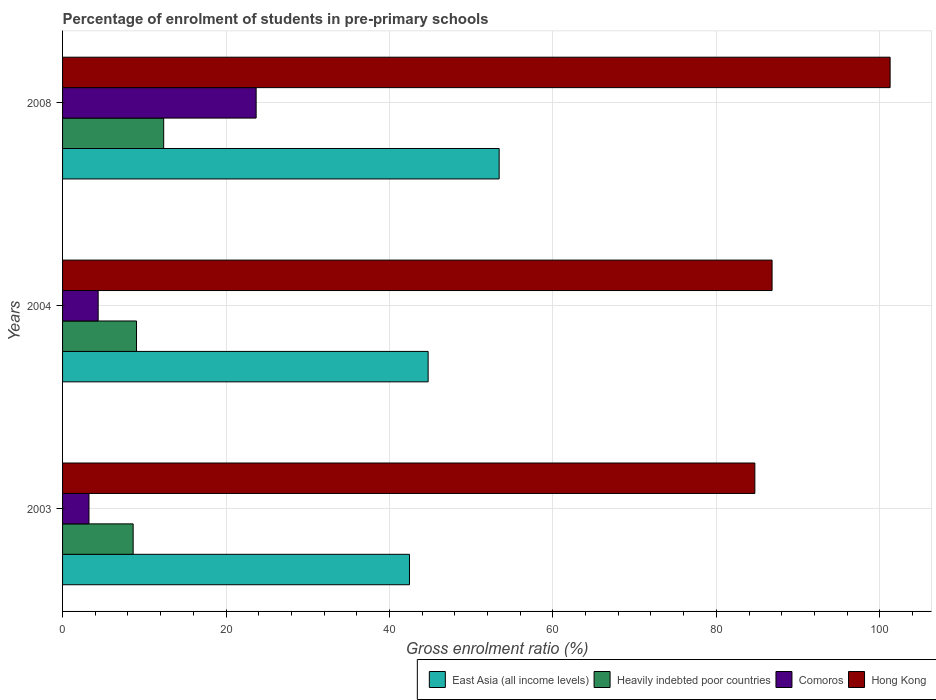How many groups of bars are there?
Ensure brevity in your answer.  3. Are the number of bars per tick equal to the number of legend labels?
Offer a very short reply. Yes. How many bars are there on the 3rd tick from the top?
Provide a short and direct response. 4. How many bars are there on the 2nd tick from the bottom?
Keep it short and to the point. 4. What is the percentage of students enrolled in pre-primary schools in East Asia (all income levels) in 2004?
Make the answer very short. 44.73. Across all years, what is the maximum percentage of students enrolled in pre-primary schools in Comoros?
Your answer should be very brief. 23.69. Across all years, what is the minimum percentage of students enrolled in pre-primary schools in Comoros?
Offer a very short reply. 3.23. In which year was the percentage of students enrolled in pre-primary schools in Comoros maximum?
Offer a terse response. 2008. What is the total percentage of students enrolled in pre-primary schools in East Asia (all income levels) in the graph?
Ensure brevity in your answer.  140.6. What is the difference between the percentage of students enrolled in pre-primary schools in Heavily indebted poor countries in 2003 and that in 2004?
Give a very brief answer. -0.41. What is the difference between the percentage of students enrolled in pre-primary schools in Hong Kong in 2004 and the percentage of students enrolled in pre-primary schools in Heavily indebted poor countries in 2003?
Ensure brevity in your answer.  78.18. What is the average percentage of students enrolled in pre-primary schools in Comoros per year?
Your answer should be compact. 10.42. In the year 2008, what is the difference between the percentage of students enrolled in pre-primary schools in Heavily indebted poor countries and percentage of students enrolled in pre-primary schools in Comoros?
Offer a terse response. -11.31. In how many years, is the percentage of students enrolled in pre-primary schools in East Asia (all income levels) greater than 96 %?
Ensure brevity in your answer.  0. What is the ratio of the percentage of students enrolled in pre-primary schools in Hong Kong in 2003 to that in 2004?
Give a very brief answer. 0.98. Is the percentage of students enrolled in pre-primary schools in East Asia (all income levels) in 2003 less than that in 2004?
Your response must be concise. Yes. What is the difference between the highest and the second highest percentage of students enrolled in pre-primary schools in Comoros?
Offer a very short reply. 19.33. What is the difference between the highest and the lowest percentage of students enrolled in pre-primary schools in Comoros?
Provide a short and direct response. 20.45. In how many years, is the percentage of students enrolled in pre-primary schools in Hong Kong greater than the average percentage of students enrolled in pre-primary schools in Hong Kong taken over all years?
Provide a short and direct response. 1. Is it the case that in every year, the sum of the percentage of students enrolled in pre-primary schools in Hong Kong and percentage of students enrolled in pre-primary schools in Comoros is greater than the sum of percentage of students enrolled in pre-primary schools in East Asia (all income levels) and percentage of students enrolled in pre-primary schools in Heavily indebted poor countries?
Ensure brevity in your answer.  Yes. What does the 3rd bar from the top in 2004 represents?
Your answer should be compact. Heavily indebted poor countries. What does the 4th bar from the bottom in 2008 represents?
Ensure brevity in your answer.  Hong Kong. Is it the case that in every year, the sum of the percentage of students enrolled in pre-primary schools in East Asia (all income levels) and percentage of students enrolled in pre-primary schools in Hong Kong is greater than the percentage of students enrolled in pre-primary schools in Comoros?
Give a very brief answer. Yes. How many bars are there?
Offer a terse response. 12. Are all the bars in the graph horizontal?
Your answer should be very brief. Yes. How many years are there in the graph?
Your answer should be very brief. 3. What is the difference between two consecutive major ticks on the X-axis?
Your response must be concise. 20. Does the graph contain any zero values?
Your answer should be very brief. No. How many legend labels are there?
Provide a short and direct response. 4. What is the title of the graph?
Keep it short and to the point. Percentage of enrolment of students in pre-primary schools. What is the Gross enrolment ratio (%) in East Asia (all income levels) in 2003?
Your answer should be compact. 42.45. What is the Gross enrolment ratio (%) in Heavily indebted poor countries in 2003?
Keep it short and to the point. 8.64. What is the Gross enrolment ratio (%) in Comoros in 2003?
Your answer should be compact. 3.23. What is the Gross enrolment ratio (%) of Hong Kong in 2003?
Provide a short and direct response. 84.71. What is the Gross enrolment ratio (%) in East Asia (all income levels) in 2004?
Provide a succinct answer. 44.73. What is the Gross enrolment ratio (%) of Heavily indebted poor countries in 2004?
Your response must be concise. 9.05. What is the Gross enrolment ratio (%) of Comoros in 2004?
Provide a succinct answer. 4.36. What is the Gross enrolment ratio (%) in Hong Kong in 2004?
Give a very brief answer. 86.82. What is the Gross enrolment ratio (%) in East Asia (all income levels) in 2008?
Your response must be concise. 53.42. What is the Gross enrolment ratio (%) of Heavily indebted poor countries in 2008?
Offer a very short reply. 12.37. What is the Gross enrolment ratio (%) of Comoros in 2008?
Keep it short and to the point. 23.69. What is the Gross enrolment ratio (%) in Hong Kong in 2008?
Give a very brief answer. 101.26. Across all years, what is the maximum Gross enrolment ratio (%) in East Asia (all income levels)?
Offer a very short reply. 53.42. Across all years, what is the maximum Gross enrolment ratio (%) in Heavily indebted poor countries?
Offer a very short reply. 12.37. Across all years, what is the maximum Gross enrolment ratio (%) in Comoros?
Make the answer very short. 23.69. Across all years, what is the maximum Gross enrolment ratio (%) of Hong Kong?
Ensure brevity in your answer.  101.26. Across all years, what is the minimum Gross enrolment ratio (%) of East Asia (all income levels)?
Provide a short and direct response. 42.45. Across all years, what is the minimum Gross enrolment ratio (%) of Heavily indebted poor countries?
Your answer should be compact. 8.64. Across all years, what is the minimum Gross enrolment ratio (%) of Comoros?
Keep it short and to the point. 3.23. Across all years, what is the minimum Gross enrolment ratio (%) in Hong Kong?
Offer a very short reply. 84.71. What is the total Gross enrolment ratio (%) in East Asia (all income levels) in the graph?
Offer a terse response. 140.6. What is the total Gross enrolment ratio (%) in Heavily indebted poor countries in the graph?
Provide a short and direct response. 30.06. What is the total Gross enrolment ratio (%) in Comoros in the graph?
Your answer should be very brief. 31.27. What is the total Gross enrolment ratio (%) in Hong Kong in the graph?
Offer a terse response. 272.79. What is the difference between the Gross enrolment ratio (%) in East Asia (all income levels) in 2003 and that in 2004?
Ensure brevity in your answer.  -2.28. What is the difference between the Gross enrolment ratio (%) of Heavily indebted poor countries in 2003 and that in 2004?
Provide a succinct answer. -0.41. What is the difference between the Gross enrolment ratio (%) in Comoros in 2003 and that in 2004?
Provide a short and direct response. -1.12. What is the difference between the Gross enrolment ratio (%) in Hong Kong in 2003 and that in 2004?
Your answer should be compact. -2.11. What is the difference between the Gross enrolment ratio (%) of East Asia (all income levels) in 2003 and that in 2008?
Offer a very short reply. -10.97. What is the difference between the Gross enrolment ratio (%) in Heavily indebted poor countries in 2003 and that in 2008?
Give a very brief answer. -3.74. What is the difference between the Gross enrolment ratio (%) in Comoros in 2003 and that in 2008?
Ensure brevity in your answer.  -20.45. What is the difference between the Gross enrolment ratio (%) in Hong Kong in 2003 and that in 2008?
Ensure brevity in your answer.  -16.55. What is the difference between the Gross enrolment ratio (%) in East Asia (all income levels) in 2004 and that in 2008?
Keep it short and to the point. -8.69. What is the difference between the Gross enrolment ratio (%) of Heavily indebted poor countries in 2004 and that in 2008?
Keep it short and to the point. -3.33. What is the difference between the Gross enrolment ratio (%) in Comoros in 2004 and that in 2008?
Provide a succinct answer. -19.33. What is the difference between the Gross enrolment ratio (%) in Hong Kong in 2004 and that in 2008?
Offer a terse response. -14.44. What is the difference between the Gross enrolment ratio (%) of East Asia (all income levels) in 2003 and the Gross enrolment ratio (%) of Heavily indebted poor countries in 2004?
Provide a succinct answer. 33.4. What is the difference between the Gross enrolment ratio (%) of East Asia (all income levels) in 2003 and the Gross enrolment ratio (%) of Comoros in 2004?
Keep it short and to the point. 38.09. What is the difference between the Gross enrolment ratio (%) of East Asia (all income levels) in 2003 and the Gross enrolment ratio (%) of Hong Kong in 2004?
Offer a terse response. -44.37. What is the difference between the Gross enrolment ratio (%) in Heavily indebted poor countries in 2003 and the Gross enrolment ratio (%) in Comoros in 2004?
Give a very brief answer. 4.28. What is the difference between the Gross enrolment ratio (%) of Heavily indebted poor countries in 2003 and the Gross enrolment ratio (%) of Hong Kong in 2004?
Provide a short and direct response. -78.18. What is the difference between the Gross enrolment ratio (%) of Comoros in 2003 and the Gross enrolment ratio (%) of Hong Kong in 2004?
Make the answer very short. -83.58. What is the difference between the Gross enrolment ratio (%) of East Asia (all income levels) in 2003 and the Gross enrolment ratio (%) of Heavily indebted poor countries in 2008?
Provide a short and direct response. 30.08. What is the difference between the Gross enrolment ratio (%) of East Asia (all income levels) in 2003 and the Gross enrolment ratio (%) of Comoros in 2008?
Your answer should be very brief. 18.76. What is the difference between the Gross enrolment ratio (%) of East Asia (all income levels) in 2003 and the Gross enrolment ratio (%) of Hong Kong in 2008?
Offer a very short reply. -58.81. What is the difference between the Gross enrolment ratio (%) in Heavily indebted poor countries in 2003 and the Gross enrolment ratio (%) in Comoros in 2008?
Give a very brief answer. -15.05. What is the difference between the Gross enrolment ratio (%) in Heavily indebted poor countries in 2003 and the Gross enrolment ratio (%) in Hong Kong in 2008?
Your answer should be compact. -92.62. What is the difference between the Gross enrolment ratio (%) of Comoros in 2003 and the Gross enrolment ratio (%) of Hong Kong in 2008?
Your response must be concise. -98.03. What is the difference between the Gross enrolment ratio (%) of East Asia (all income levels) in 2004 and the Gross enrolment ratio (%) of Heavily indebted poor countries in 2008?
Your answer should be compact. 32.36. What is the difference between the Gross enrolment ratio (%) in East Asia (all income levels) in 2004 and the Gross enrolment ratio (%) in Comoros in 2008?
Offer a very short reply. 21.05. What is the difference between the Gross enrolment ratio (%) of East Asia (all income levels) in 2004 and the Gross enrolment ratio (%) of Hong Kong in 2008?
Offer a very short reply. -56.53. What is the difference between the Gross enrolment ratio (%) in Heavily indebted poor countries in 2004 and the Gross enrolment ratio (%) in Comoros in 2008?
Keep it short and to the point. -14.64. What is the difference between the Gross enrolment ratio (%) in Heavily indebted poor countries in 2004 and the Gross enrolment ratio (%) in Hong Kong in 2008?
Offer a terse response. -92.21. What is the difference between the Gross enrolment ratio (%) in Comoros in 2004 and the Gross enrolment ratio (%) in Hong Kong in 2008?
Provide a short and direct response. -96.9. What is the average Gross enrolment ratio (%) in East Asia (all income levels) per year?
Ensure brevity in your answer.  46.87. What is the average Gross enrolment ratio (%) in Heavily indebted poor countries per year?
Provide a succinct answer. 10.02. What is the average Gross enrolment ratio (%) in Comoros per year?
Offer a terse response. 10.42. What is the average Gross enrolment ratio (%) in Hong Kong per year?
Offer a very short reply. 90.93. In the year 2003, what is the difference between the Gross enrolment ratio (%) in East Asia (all income levels) and Gross enrolment ratio (%) in Heavily indebted poor countries?
Ensure brevity in your answer.  33.81. In the year 2003, what is the difference between the Gross enrolment ratio (%) of East Asia (all income levels) and Gross enrolment ratio (%) of Comoros?
Offer a terse response. 39.22. In the year 2003, what is the difference between the Gross enrolment ratio (%) in East Asia (all income levels) and Gross enrolment ratio (%) in Hong Kong?
Provide a succinct answer. -42.26. In the year 2003, what is the difference between the Gross enrolment ratio (%) in Heavily indebted poor countries and Gross enrolment ratio (%) in Comoros?
Keep it short and to the point. 5.4. In the year 2003, what is the difference between the Gross enrolment ratio (%) in Heavily indebted poor countries and Gross enrolment ratio (%) in Hong Kong?
Ensure brevity in your answer.  -76.07. In the year 2003, what is the difference between the Gross enrolment ratio (%) in Comoros and Gross enrolment ratio (%) in Hong Kong?
Your answer should be very brief. -81.48. In the year 2004, what is the difference between the Gross enrolment ratio (%) in East Asia (all income levels) and Gross enrolment ratio (%) in Heavily indebted poor countries?
Offer a very short reply. 35.69. In the year 2004, what is the difference between the Gross enrolment ratio (%) in East Asia (all income levels) and Gross enrolment ratio (%) in Comoros?
Provide a short and direct response. 40.38. In the year 2004, what is the difference between the Gross enrolment ratio (%) of East Asia (all income levels) and Gross enrolment ratio (%) of Hong Kong?
Your answer should be compact. -42.08. In the year 2004, what is the difference between the Gross enrolment ratio (%) of Heavily indebted poor countries and Gross enrolment ratio (%) of Comoros?
Give a very brief answer. 4.69. In the year 2004, what is the difference between the Gross enrolment ratio (%) of Heavily indebted poor countries and Gross enrolment ratio (%) of Hong Kong?
Make the answer very short. -77.77. In the year 2004, what is the difference between the Gross enrolment ratio (%) in Comoros and Gross enrolment ratio (%) in Hong Kong?
Give a very brief answer. -82.46. In the year 2008, what is the difference between the Gross enrolment ratio (%) of East Asia (all income levels) and Gross enrolment ratio (%) of Heavily indebted poor countries?
Provide a succinct answer. 41.05. In the year 2008, what is the difference between the Gross enrolment ratio (%) in East Asia (all income levels) and Gross enrolment ratio (%) in Comoros?
Offer a very short reply. 29.74. In the year 2008, what is the difference between the Gross enrolment ratio (%) of East Asia (all income levels) and Gross enrolment ratio (%) of Hong Kong?
Provide a short and direct response. -47.84. In the year 2008, what is the difference between the Gross enrolment ratio (%) in Heavily indebted poor countries and Gross enrolment ratio (%) in Comoros?
Make the answer very short. -11.31. In the year 2008, what is the difference between the Gross enrolment ratio (%) of Heavily indebted poor countries and Gross enrolment ratio (%) of Hong Kong?
Your answer should be very brief. -88.89. In the year 2008, what is the difference between the Gross enrolment ratio (%) in Comoros and Gross enrolment ratio (%) in Hong Kong?
Provide a succinct answer. -77.57. What is the ratio of the Gross enrolment ratio (%) of East Asia (all income levels) in 2003 to that in 2004?
Make the answer very short. 0.95. What is the ratio of the Gross enrolment ratio (%) of Heavily indebted poor countries in 2003 to that in 2004?
Ensure brevity in your answer.  0.95. What is the ratio of the Gross enrolment ratio (%) in Comoros in 2003 to that in 2004?
Your response must be concise. 0.74. What is the ratio of the Gross enrolment ratio (%) in Hong Kong in 2003 to that in 2004?
Offer a terse response. 0.98. What is the ratio of the Gross enrolment ratio (%) in East Asia (all income levels) in 2003 to that in 2008?
Your answer should be compact. 0.79. What is the ratio of the Gross enrolment ratio (%) of Heavily indebted poor countries in 2003 to that in 2008?
Your answer should be compact. 0.7. What is the ratio of the Gross enrolment ratio (%) in Comoros in 2003 to that in 2008?
Your answer should be compact. 0.14. What is the ratio of the Gross enrolment ratio (%) in Hong Kong in 2003 to that in 2008?
Your answer should be very brief. 0.84. What is the ratio of the Gross enrolment ratio (%) in East Asia (all income levels) in 2004 to that in 2008?
Provide a short and direct response. 0.84. What is the ratio of the Gross enrolment ratio (%) in Heavily indebted poor countries in 2004 to that in 2008?
Offer a very short reply. 0.73. What is the ratio of the Gross enrolment ratio (%) of Comoros in 2004 to that in 2008?
Ensure brevity in your answer.  0.18. What is the ratio of the Gross enrolment ratio (%) of Hong Kong in 2004 to that in 2008?
Provide a succinct answer. 0.86. What is the difference between the highest and the second highest Gross enrolment ratio (%) of East Asia (all income levels)?
Provide a short and direct response. 8.69. What is the difference between the highest and the second highest Gross enrolment ratio (%) of Heavily indebted poor countries?
Your response must be concise. 3.33. What is the difference between the highest and the second highest Gross enrolment ratio (%) of Comoros?
Offer a very short reply. 19.33. What is the difference between the highest and the second highest Gross enrolment ratio (%) in Hong Kong?
Offer a terse response. 14.44. What is the difference between the highest and the lowest Gross enrolment ratio (%) of East Asia (all income levels)?
Offer a very short reply. 10.97. What is the difference between the highest and the lowest Gross enrolment ratio (%) of Heavily indebted poor countries?
Offer a very short reply. 3.74. What is the difference between the highest and the lowest Gross enrolment ratio (%) of Comoros?
Give a very brief answer. 20.45. What is the difference between the highest and the lowest Gross enrolment ratio (%) of Hong Kong?
Provide a succinct answer. 16.55. 